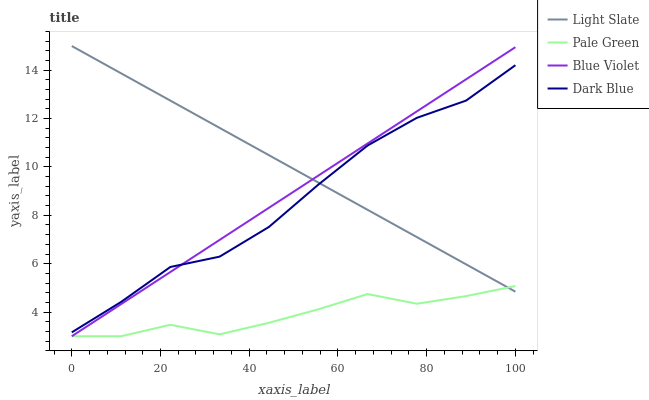Does Pale Green have the minimum area under the curve?
Answer yes or no. Yes. Does Light Slate have the maximum area under the curve?
Answer yes or no. Yes. Does Dark Blue have the minimum area under the curve?
Answer yes or no. No. Does Dark Blue have the maximum area under the curve?
Answer yes or no. No. Is Blue Violet the smoothest?
Answer yes or no. Yes. Is Dark Blue the roughest?
Answer yes or no. Yes. Is Pale Green the smoothest?
Answer yes or no. No. Is Pale Green the roughest?
Answer yes or no. No. Does Pale Green have the lowest value?
Answer yes or no. Yes. Does Dark Blue have the lowest value?
Answer yes or no. No. Does Light Slate have the highest value?
Answer yes or no. Yes. Does Dark Blue have the highest value?
Answer yes or no. No. Is Pale Green less than Dark Blue?
Answer yes or no. Yes. Is Dark Blue greater than Pale Green?
Answer yes or no. Yes. Does Light Slate intersect Pale Green?
Answer yes or no. Yes. Is Light Slate less than Pale Green?
Answer yes or no. No. Is Light Slate greater than Pale Green?
Answer yes or no. No. Does Pale Green intersect Dark Blue?
Answer yes or no. No. 